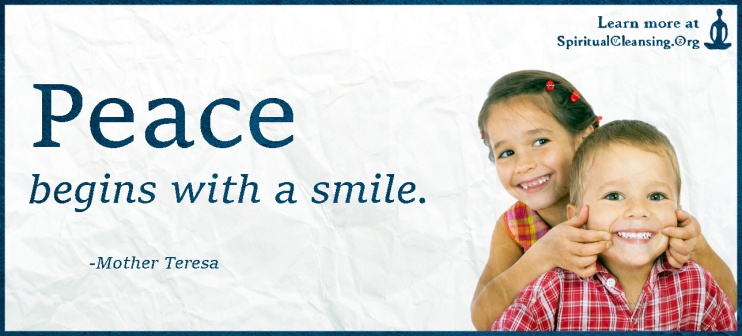Analyze the image in a comprehensive and detailed manner. The image encapsulates a heartwarming and motivational scene centered around the theme of peace. In the foreground, two children – a boy and a girl – smile warmly, with the girl in a pink top and the boy in a red plaid shirt. Their expressive poses, making peace signs, serve not only as a playful gesture but also resonate deeply with the central message of the banner: 'Peace begins with a smile.' This quote, attributed to Mother Teresa, is prominently displayed in bold, blue letters, which complements the peaceful blue background, intensifying the theme of tranquility and positivity.

The inclusion of the website, 'SpiritualCleansing.org', suggests a broader context for the message, potentially inviting viewers to explore deeper discussions or resources related to peace and spiritual well-being. The crumpled paper texture of the banner adds a tactile element to the visual experience, suggesting authenticity and approachability. This thoughtful composition thus not only captures attention but also eloquently communicates the profound connection between simplicity and global harmony. 